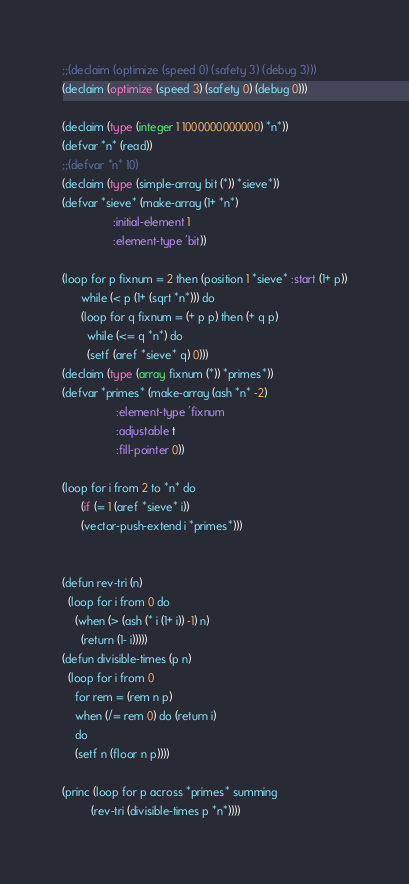Convert code to text. <code><loc_0><loc_0><loc_500><loc_500><_Lisp_>;;(declaim (optimize (speed 0) (safety 3) (debug 3)))
(declaim (optimize (speed 3) (safety 0) (debug 0)))

(declaim (type (integer 1 1000000000000) *n*))
(defvar *n* (read))
;;(defvar *n* 10)
(declaim (type (simple-array bit (*)) *sieve*))
(defvar *sieve* (make-array (1+ *n*)
			    :initial-element 1
			    :element-type 'bit))

(loop for p fixnum = 2 then (position 1 *sieve* :start (1+ p))
      while (< p (1+ (sqrt *n*))) do
      (loop for q fixnum = (+ p p) then (+ q p)
	    while (<= q *n*) do
	    (setf (aref *sieve* q) 0)))
(declaim (type (array fixnum (*)) *primes*))
(defvar *primes* (make-array (ash *n* -2)
			     :element-type 'fixnum
			     :adjustable t
			     :fill-pointer 0))

(loop for i from 2 to *n* do
      (if (= 1 (aref *sieve* i))
	  (vector-push-extend i *primes*)))


(defun rev-tri (n)
  (loop for i from 0 do
	(when (> (ash (* i (1+ i)) -1) n)
	  (return (1- i)))))
(defun divisible-times (p n)
  (loop for i from 0
	for rem = (rem n p)
	when (/= rem 0) do (return i)
	do
	(setf n (floor n p))))

(princ (loop for p across *primes* summing
	     (rev-tri (divisible-times p *n*))))
</code> 